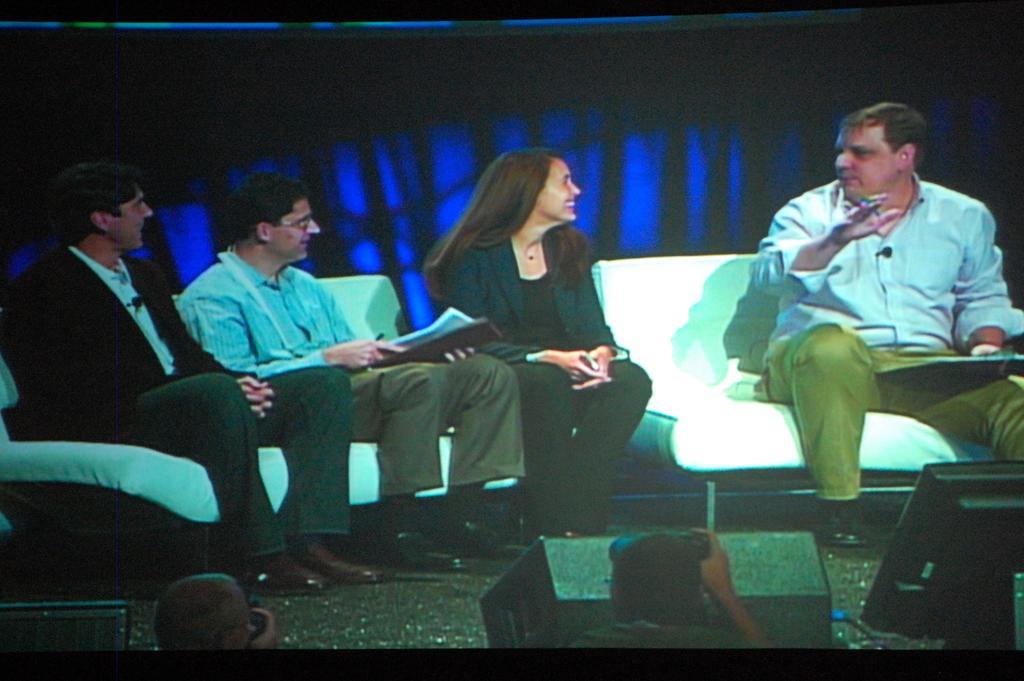In one or two sentences, can you explain what this image depicts? In this picture we can see few people and four people sitting on the sofas, on the right side of the image we can see a man, he is holding a pen and a notepad. 